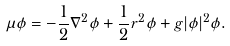Convert formula to latex. <formula><loc_0><loc_0><loc_500><loc_500>\mu \phi = - \frac { 1 } { 2 } \nabla ^ { 2 } \phi + \frac { 1 } { 2 } r ^ { 2 } \phi + g | \phi | ^ { 2 } \phi .</formula> 